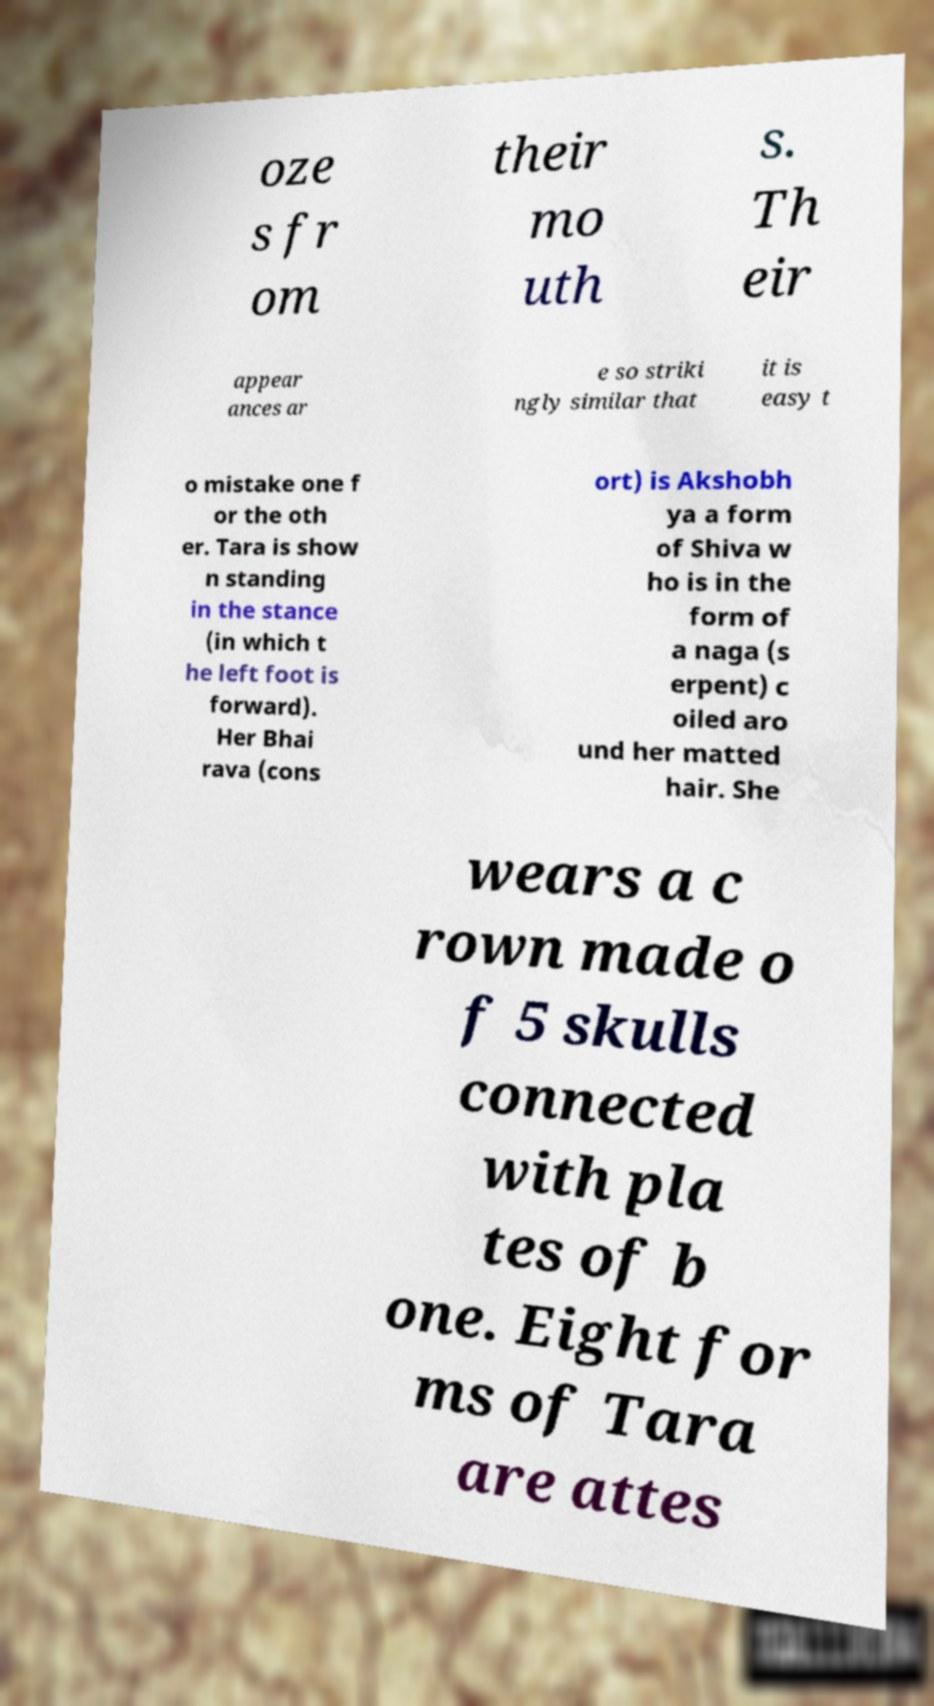There's text embedded in this image that I need extracted. Can you transcribe it verbatim? oze s fr om their mo uth s. Th eir appear ances ar e so striki ngly similar that it is easy t o mistake one f or the oth er. Tara is show n standing in the stance (in which t he left foot is forward). Her Bhai rava (cons ort) is Akshobh ya a form of Shiva w ho is in the form of a naga (s erpent) c oiled aro und her matted hair. She wears a c rown made o f 5 skulls connected with pla tes of b one. Eight for ms of Tara are attes 